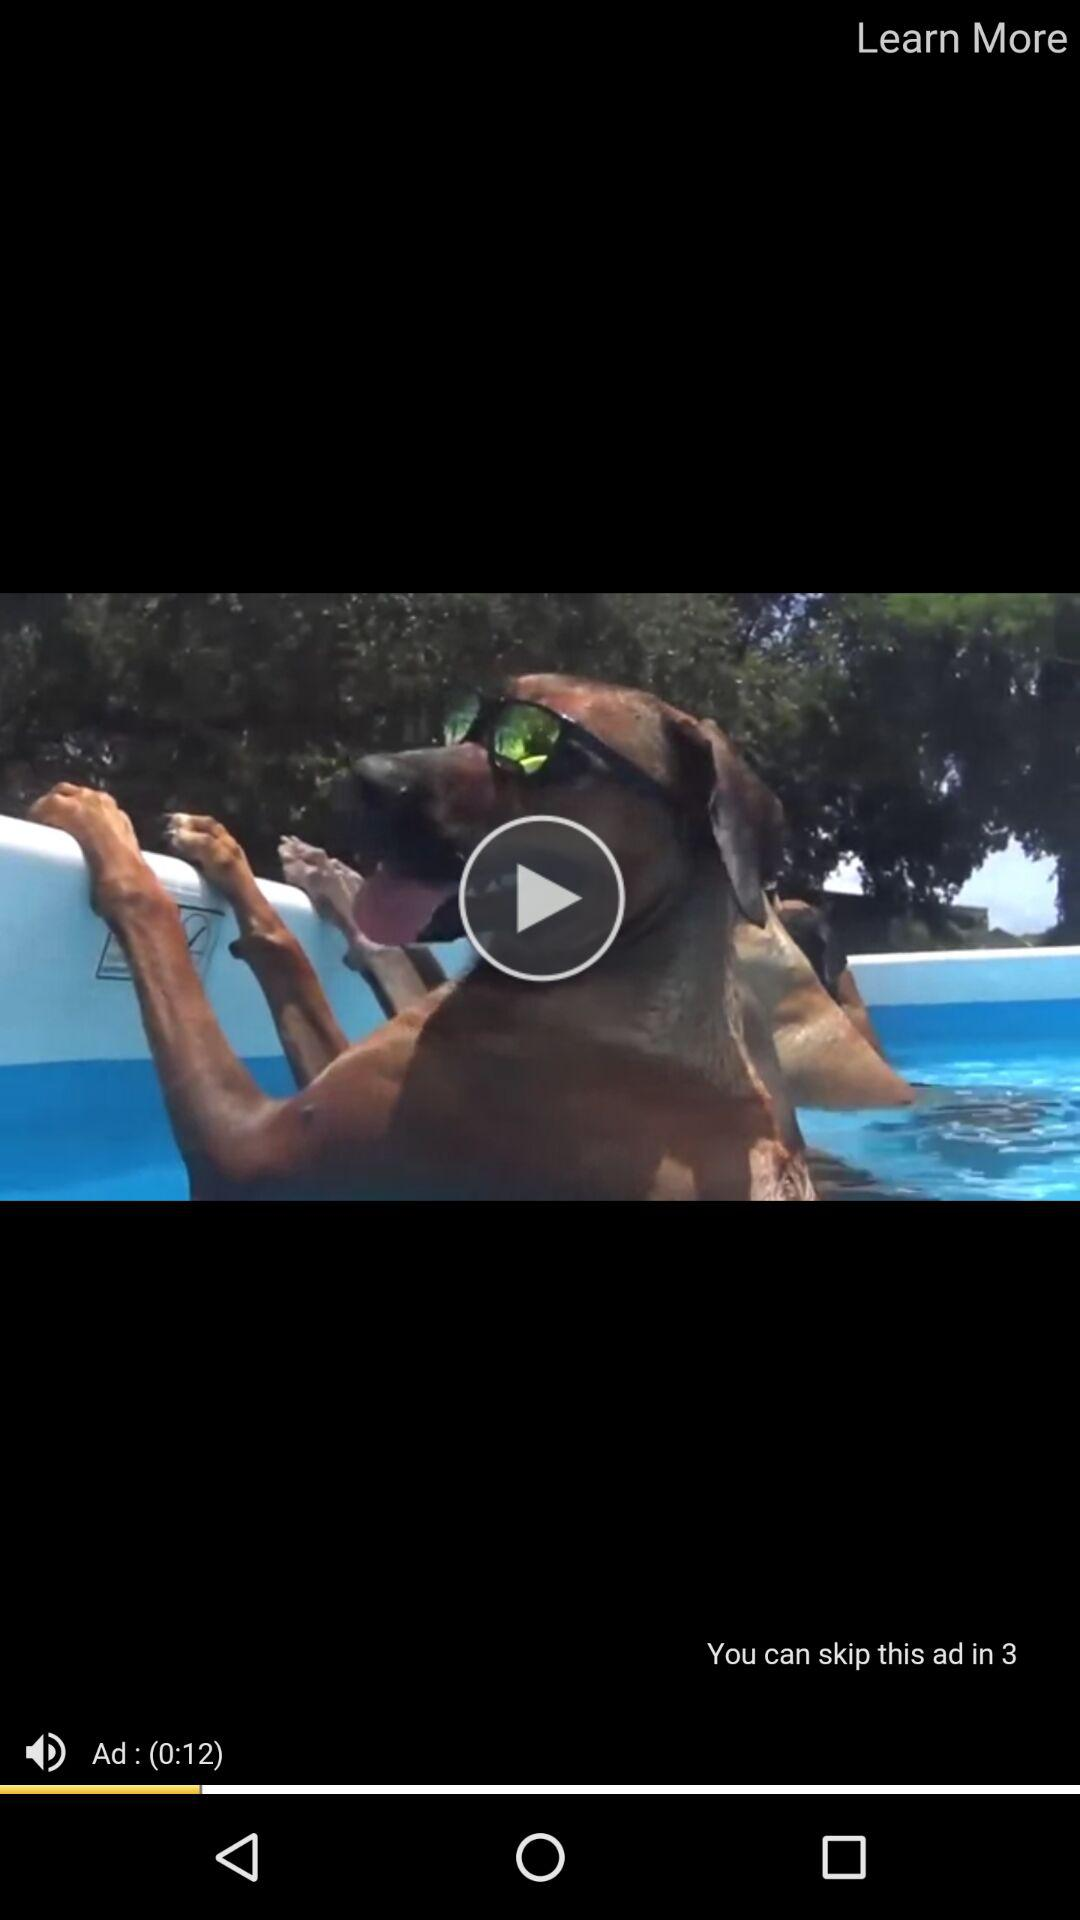How many more seconds until the ad can be skipped?
Answer the question using a single word or phrase. 3 